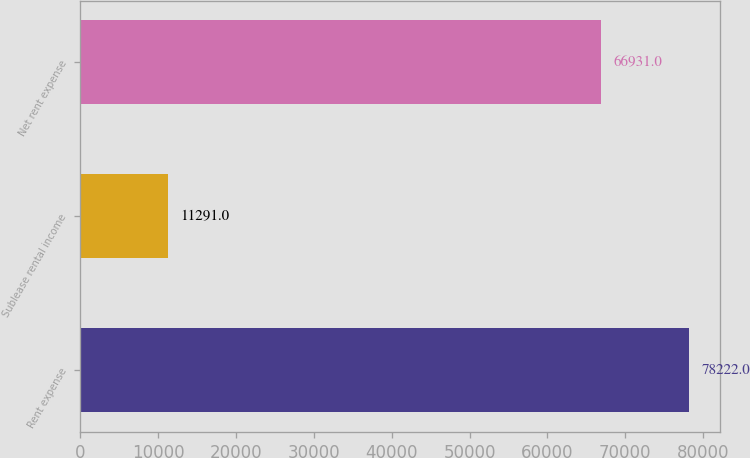Convert chart to OTSL. <chart><loc_0><loc_0><loc_500><loc_500><bar_chart><fcel>Rent expense<fcel>Sublease rental income<fcel>Net rent expense<nl><fcel>78222<fcel>11291<fcel>66931<nl></chart> 